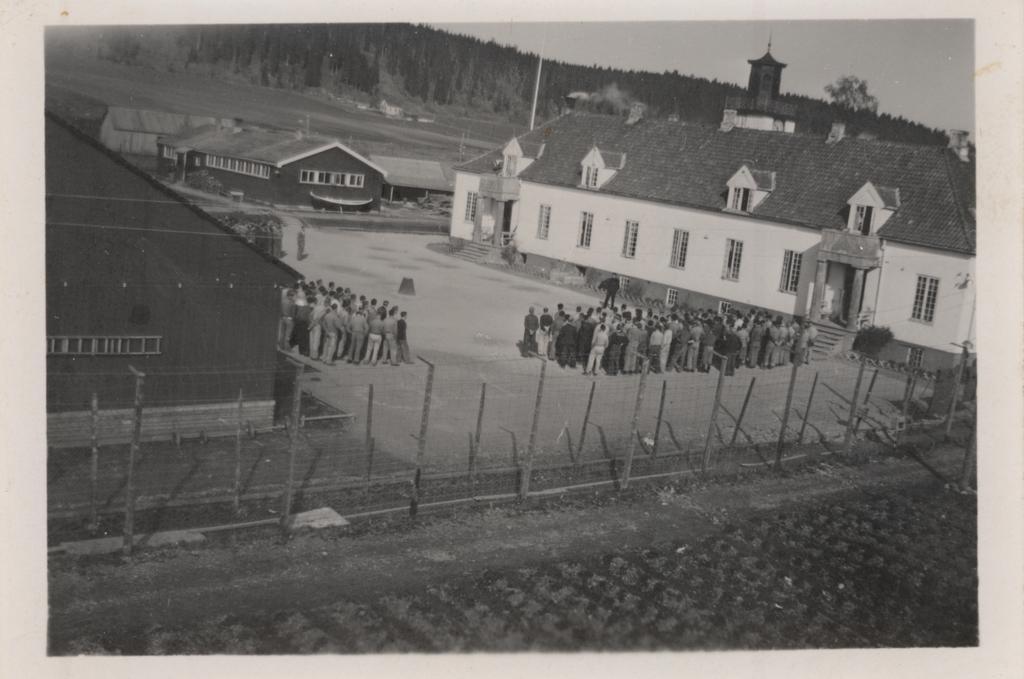Could you give a brief overview of what you see in this image? This is a black and white image, in this image there are houses and there are groups of persons and there is a fencing, in the background there are trees. 